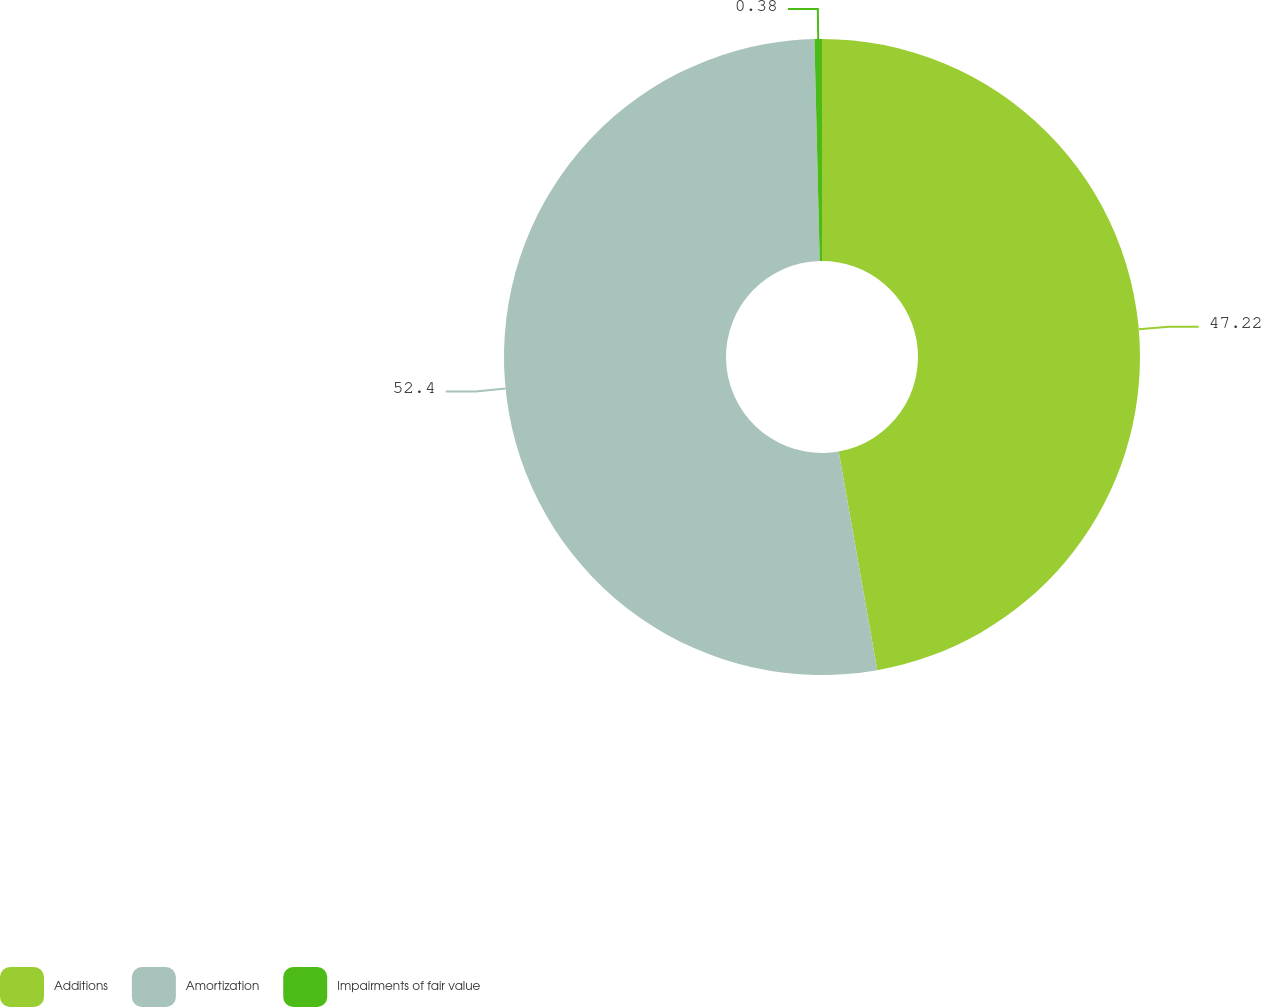Convert chart to OTSL. <chart><loc_0><loc_0><loc_500><loc_500><pie_chart><fcel>Additions<fcel>Amortization<fcel>Impairments of fair value<nl><fcel>47.22%<fcel>52.4%<fcel>0.38%<nl></chart> 